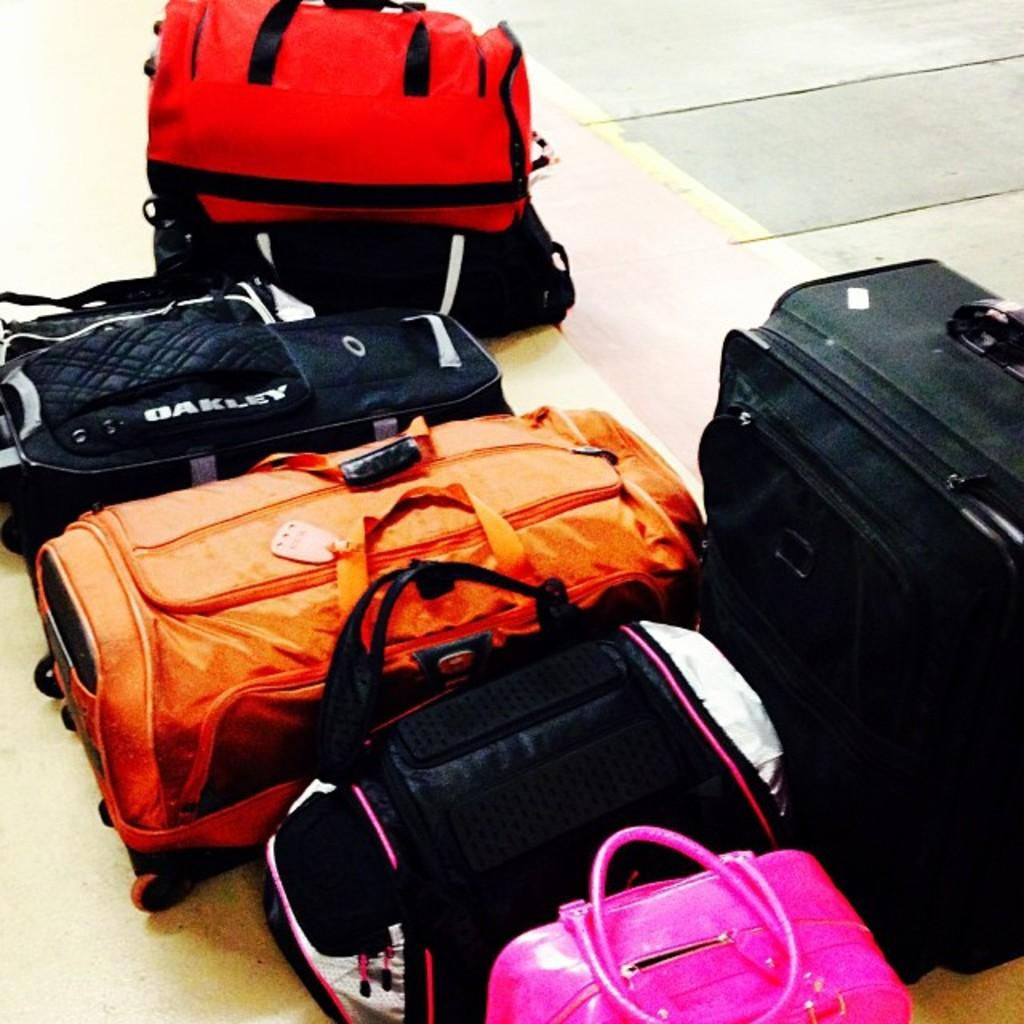What objects are present on the floor in the image? There are many bags on the floor in the image. Can you describe the bags in more detail? Unfortunately, the facts provided do not give any additional details about the bags. What type of drum can be heard playing in the background of the image? There is no drum or any sound present in the image; it only shows bags on the floor. 